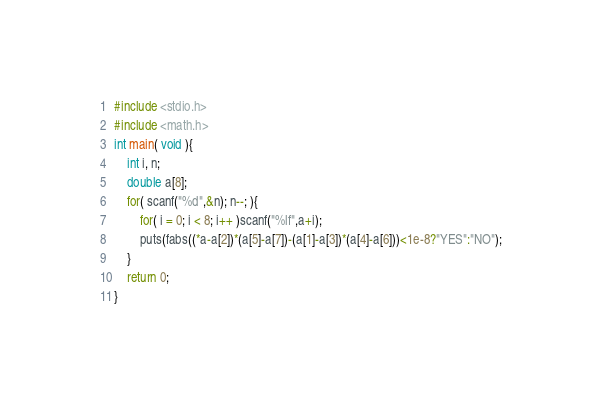<code> <loc_0><loc_0><loc_500><loc_500><_C_>#include <stdio.h>
#include <math.h>
int main( void ){
	int i, n;
	double a[8];
	for( scanf("%d",&n); n--; ){
		for( i = 0; i < 8; i++ )scanf("%lf",a+i);
		puts(fabs((*a-a[2])*(a[5]-a[7])-(a[1]-a[3])*(a[4]-a[6]))<1e-8?"YES":"NO");
	}
	return 0;
}</code> 